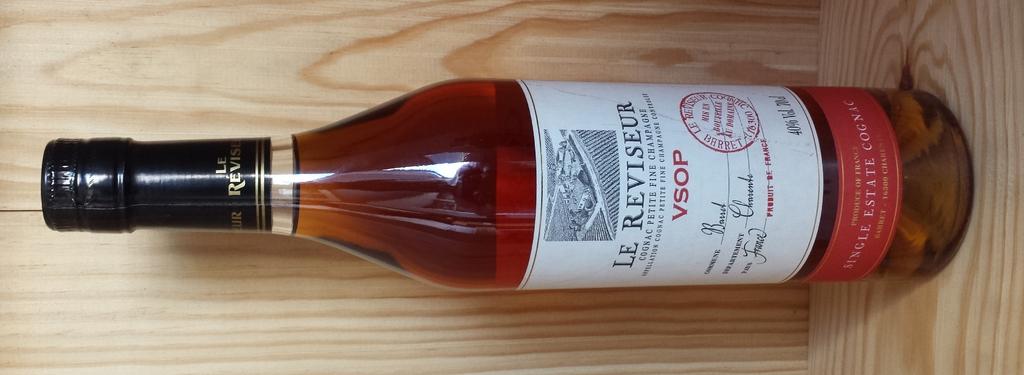What type of alcohol is in this bottle?
Offer a terse response. Wine. What is the brand name of the alcohol?
Your answer should be very brief. Le reviseur. 